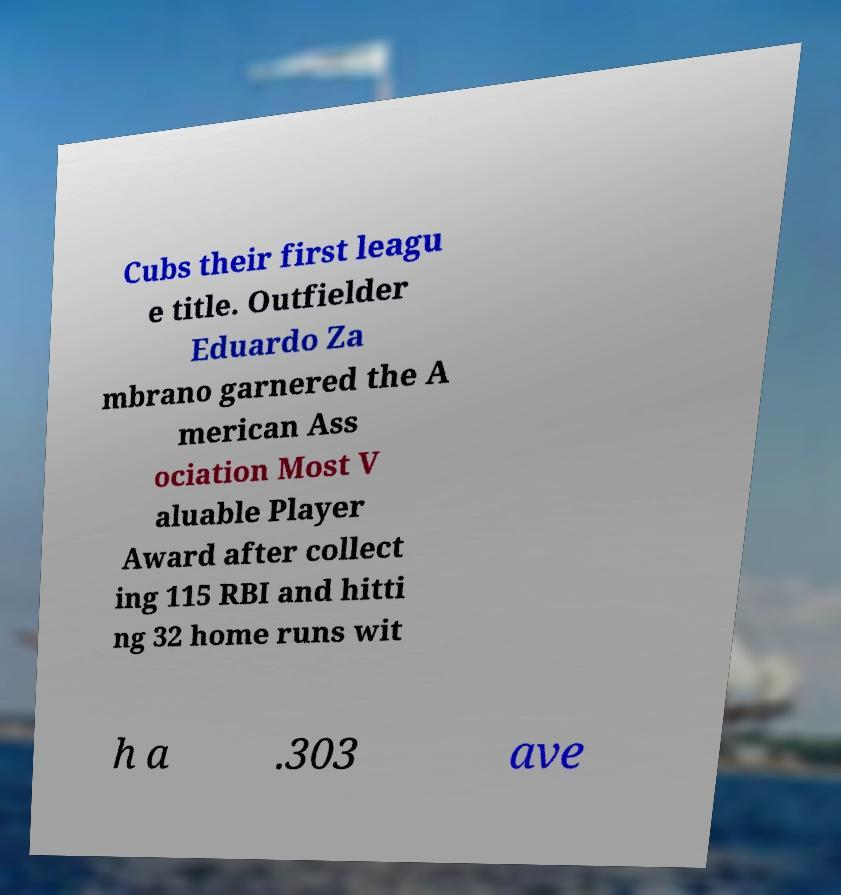Could you assist in decoding the text presented in this image and type it out clearly? Cubs their first leagu e title. Outfielder Eduardo Za mbrano garnered the A merican Ass ociation Most V aluable Player Award after collect ing 115 RBI and hitti ng 32 home runs wit h a .303 ave 